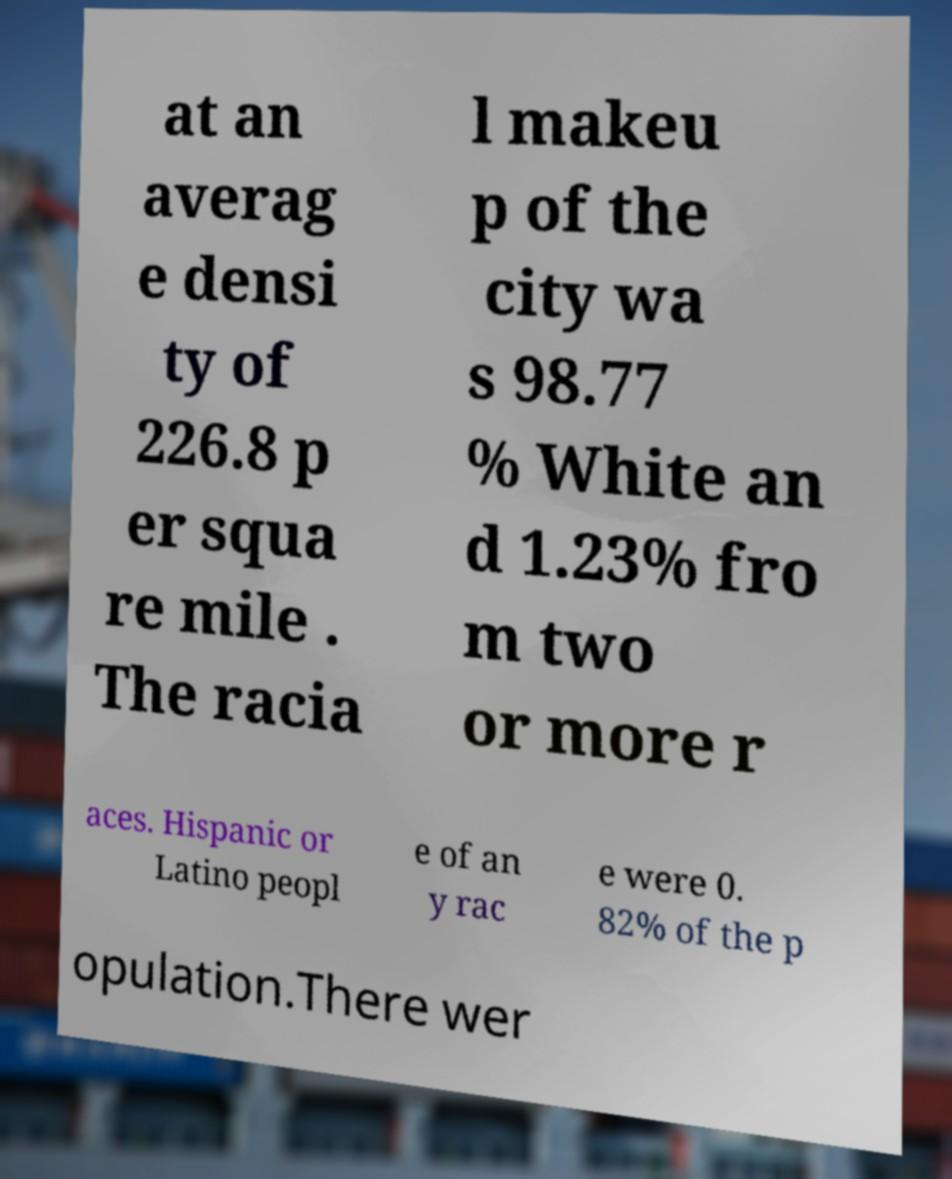Please identify and transcribe the text found in this image. at an averag e densi ty of 226.8 p er squa re mile . The racia l makeu p of the city wa s 98.77 % White an d 1.23% fro m two or more r aces. Hispanic or Latino peopl e of an y rac e were 0. 82% of the p opulation.There wer 